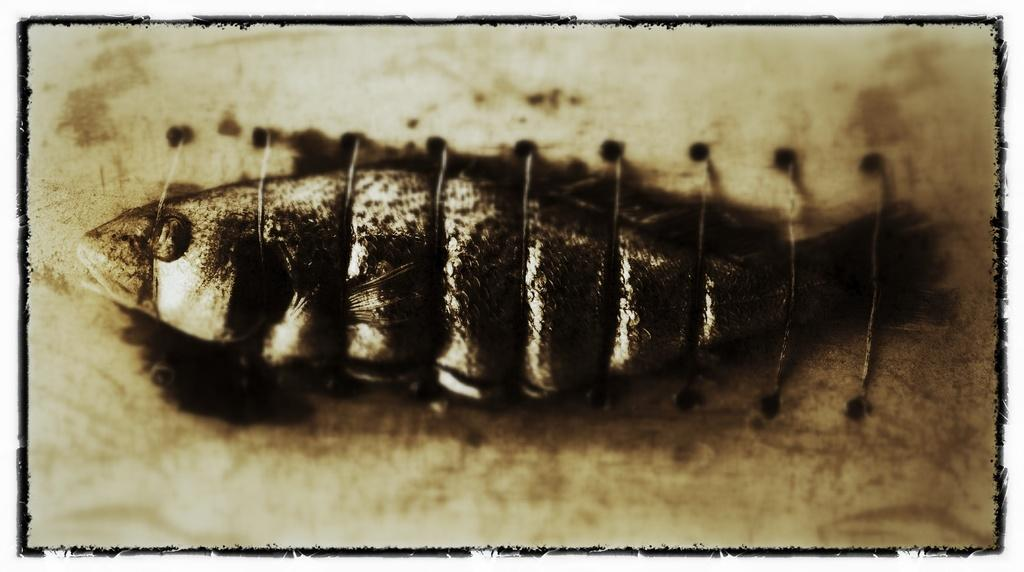What is the main subject of the image? There is a picture in the image. What is depicted in the picture? The picture contains a fish. Can you describe any additional details about the fish in the picture? There are threads tied horizontally on the fish's body. Why is the fish crying in the image? There is no indication in the image that the fish is crying, as fish do not have the ability to cry. 